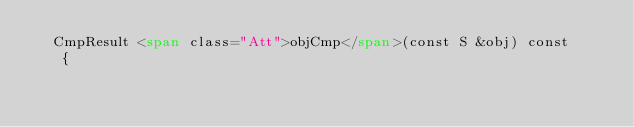<code> <loc_0><loc_0><loc_500><loc_500><_HTML_>  CmpResult <span class="Att">objCmp</span>(const S &obj) const
   {</code> 